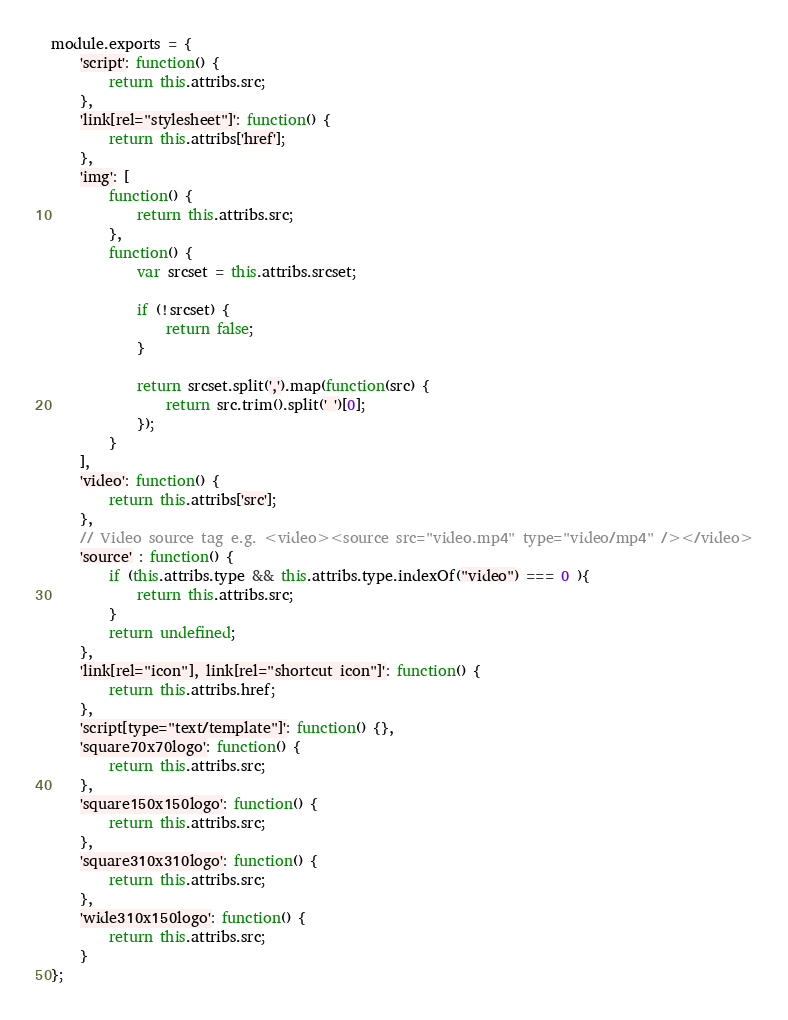<code> <loc_0><loc_0><loc_500><loc_500><_JavaScript_>module.exports = {
    'script': function() {
        return this.attribs.src;
    },
    'link[rel="stylesheet"]': function() {
        return this.attribs['href'];
    },
    'img': [
        function() {
            return this.attribs.src;
        },
        function() {
            var srcset = this.attribs.srcset;

            if (!srcset) {
                return false;
            }

            return srcset.split(',').map(function(src) {
                return src.trim().split(' ')[0];
            });
        }
    ],
    'video': function() {
        return this.attribs['src'];
    },
    // Video source tag e.g. <video><source src="video.mp4" type="video/mp4" /></video>
    'source' : function() {
        if (this.attribs.type && this.attribs.type.indexOf("video") === 0 ){
            return this.attribs.src;
        }
        return undefined;
    },
    'link[rel="icon"], link[rel="shortcut icon"]': function() {
        return this.attribs.href;
    },
    'script[type="text/template"]': function() {},
    'square70x70logo': function() {
        return this.attribs.src;
    },
    'square150x150logo': function() {
        return this.attribs.src;
    },
    'square310x310logo': function() {
        return this.attribs.src;
    },
    'wide310x150logo': function() {
        return this.attribs.src;
    }
};
</code> 